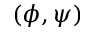<formula> <loc_0><loc_0><loc_500><loc_500>( \phi , \psi )</formula> 